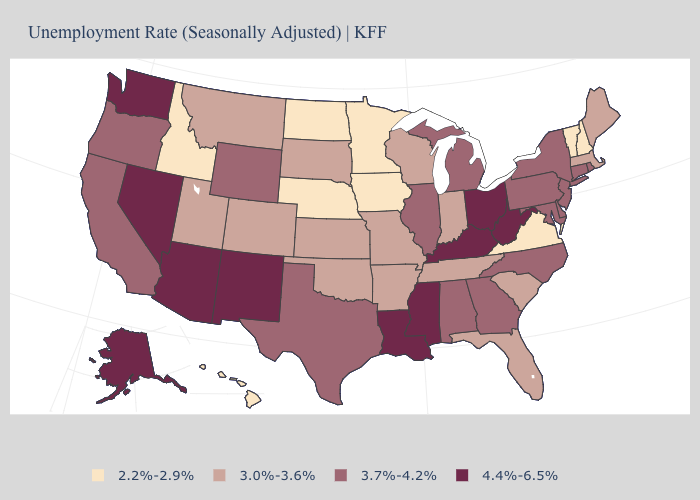Does the first symbol in the legend represent the smallest category?
Give a very brief answer. Yes. Does the first symbol in the legend represent the smallest category?
Give a very brief answer. Yes. What is the value of Virginia?
Quick response, please. 2.2%-2.9%. Does Texas have the same value as Wyoming?
Keep it brief. Yes. Does West Virginia have the same value as Kentucky?
Keep it brief. Yes. Which states hav the highest value in the West?
Concise answer only. Alaska, Arizona, Nevada, New Mexico, Washington. Among the states that border Indiana , which have the highest value?
Give a very brief answer. Kentucky, Ohio. Does Texas have a lower value than Mississippi?
Concise answer only. Yes. What is the value of Montana?
Answer briefly. 3.0%-3.6%. Name the states that have a value in the range 2.2%-2.9%?
Quick response, please. Hawaii, Idaho, Iowa, Minnesota, Nebraska, New Hampshire, North Dakota, Vermont, Virginia. Does the map have missing data?
Be succinct. No. Among the states that border Maryland , does Virginia have the lowest value?
Write a very short answer. Yes. Does Massachusetts have the highest value in the Northeast?
Concise answer only. No. What is the value of California?
Quick response, please. 3.7%-4.2%. Does Hawaii have the lowest value in the USA?
Give a very brief answer. Yes. 